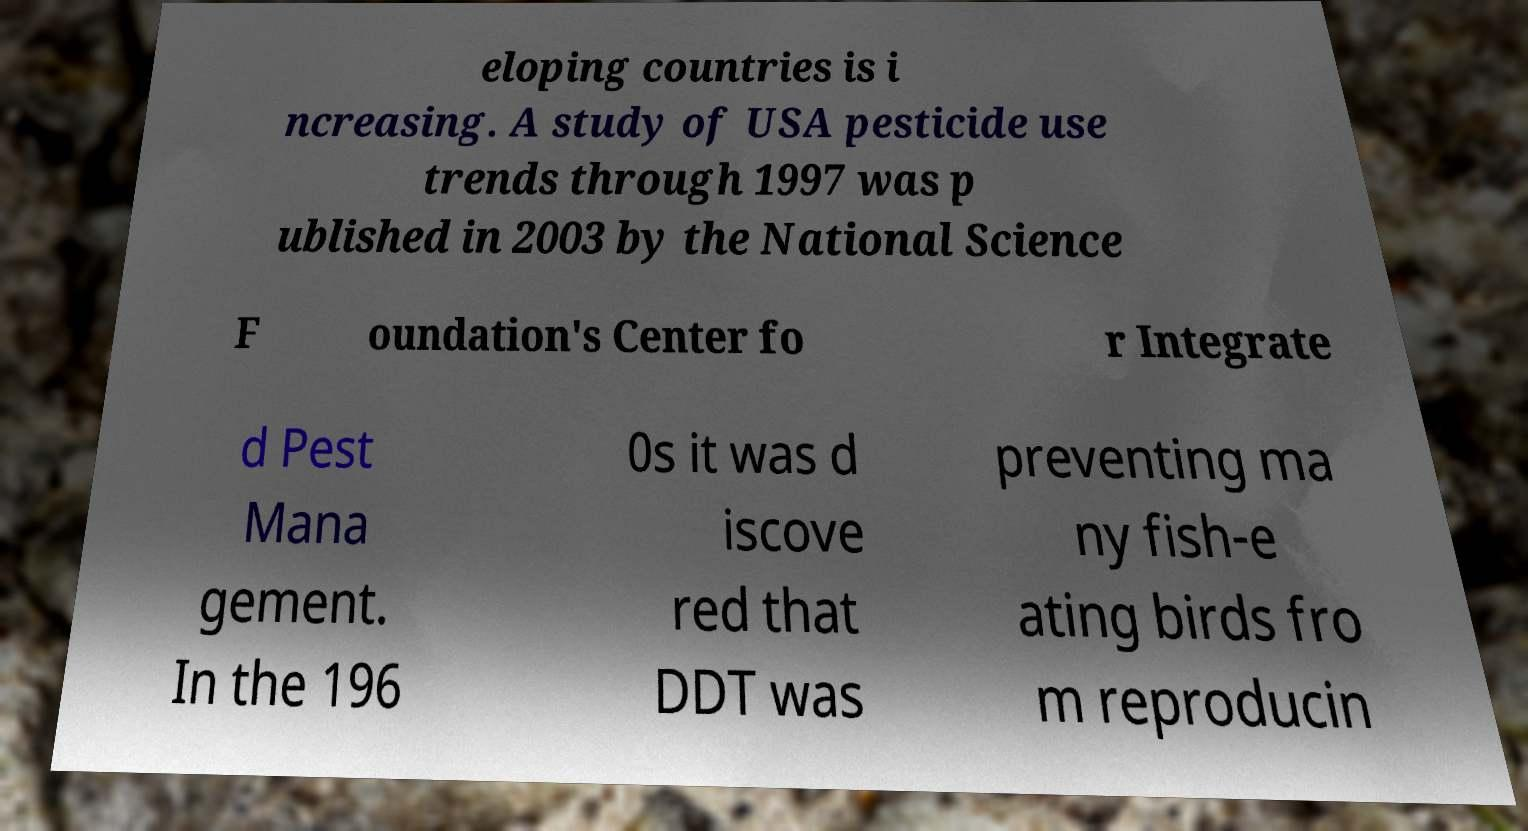What messages or text are displayed in this image? I need them in a readable, typed format. eloping countries is i ncreasing. A study of USA pesticide use trends through 1997 was p ublished in 2003 by the National Science F oundation's Center fo r Integrate d Pest Mana gement. In the 196 0s it was d iscove red that DDT was preventing ma ny fish-e ating birds fro m reproducin 